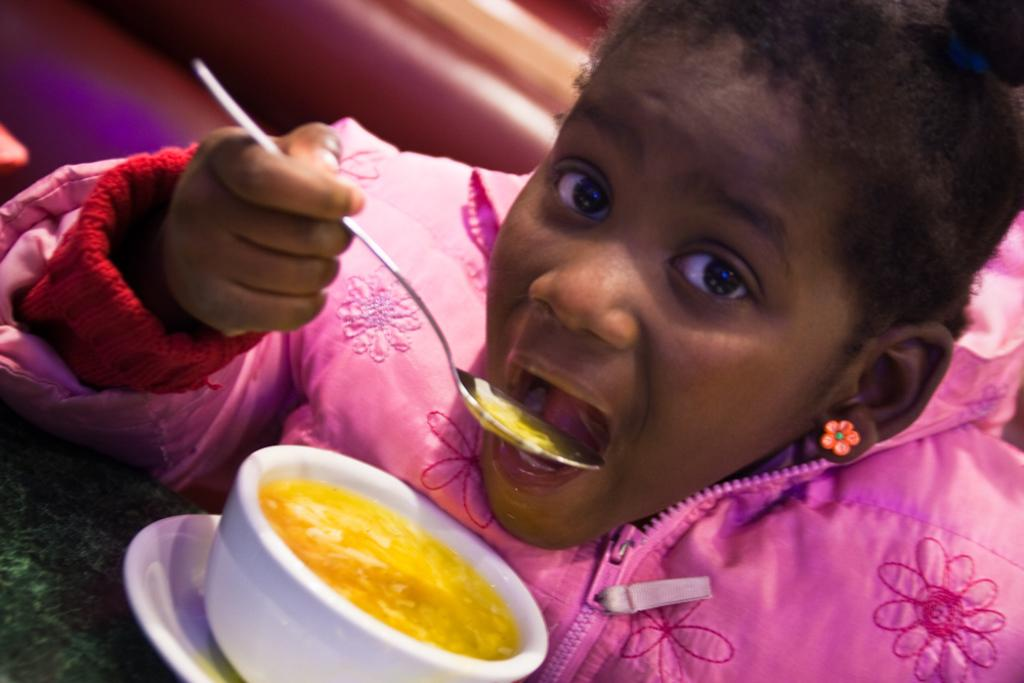What is the main subject of the image? The main subject of the image is a child. What is the child wearing in the image? The child is wearing a pink jacket. What is the child doing in the image? The child is eating with a spoon. What other object is present in the image? There is a teacup in the image. How many chairs are visible in the image? There are no chairs visible in the image. 